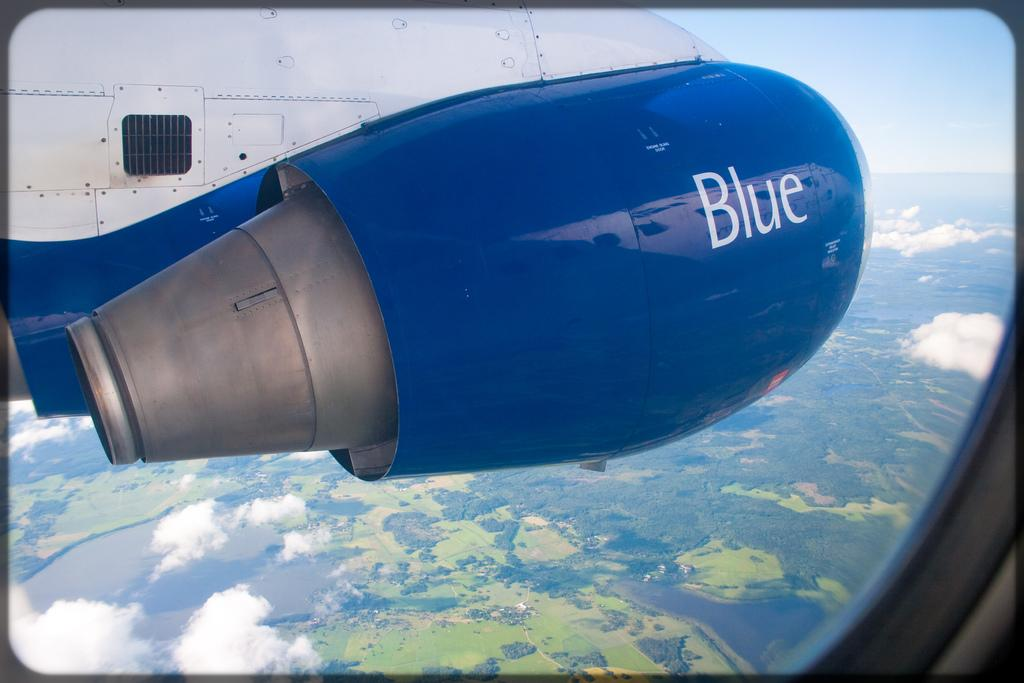<image>
Render a clear and concise summary of the photo. the view of a blue turbine while the plane is in mid flight. 